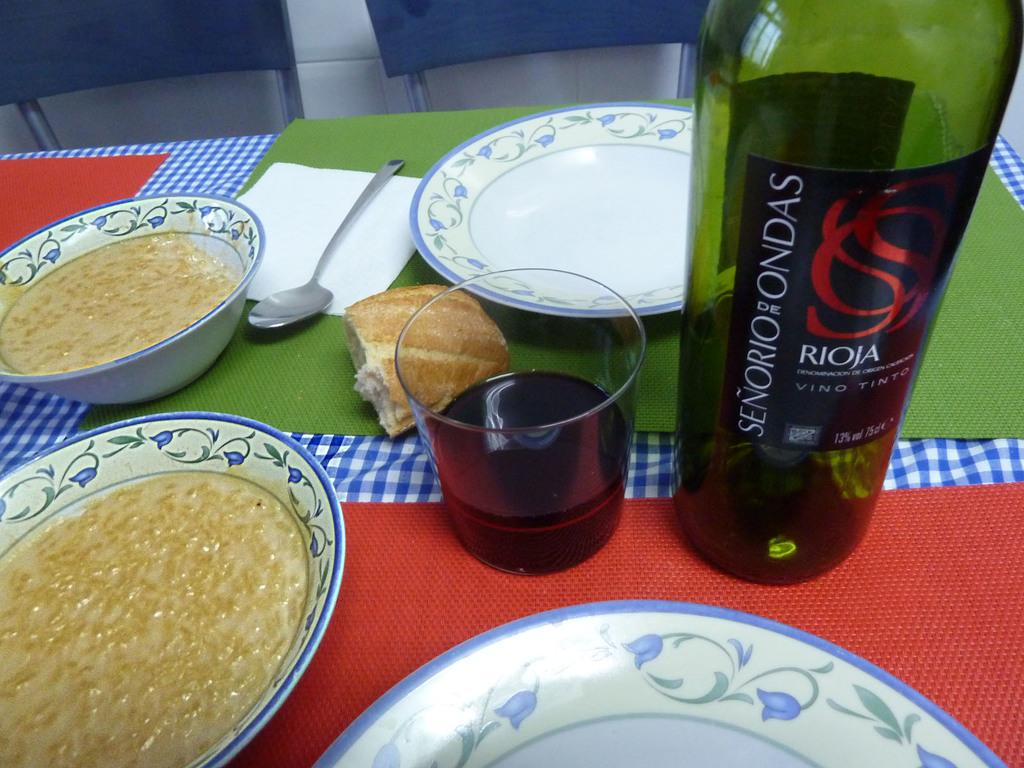<image>
Summarize the visual content of the image. A bottle of Senorio De Ondas Vino Tinto wine is on a table with bowls of oatmeal. 